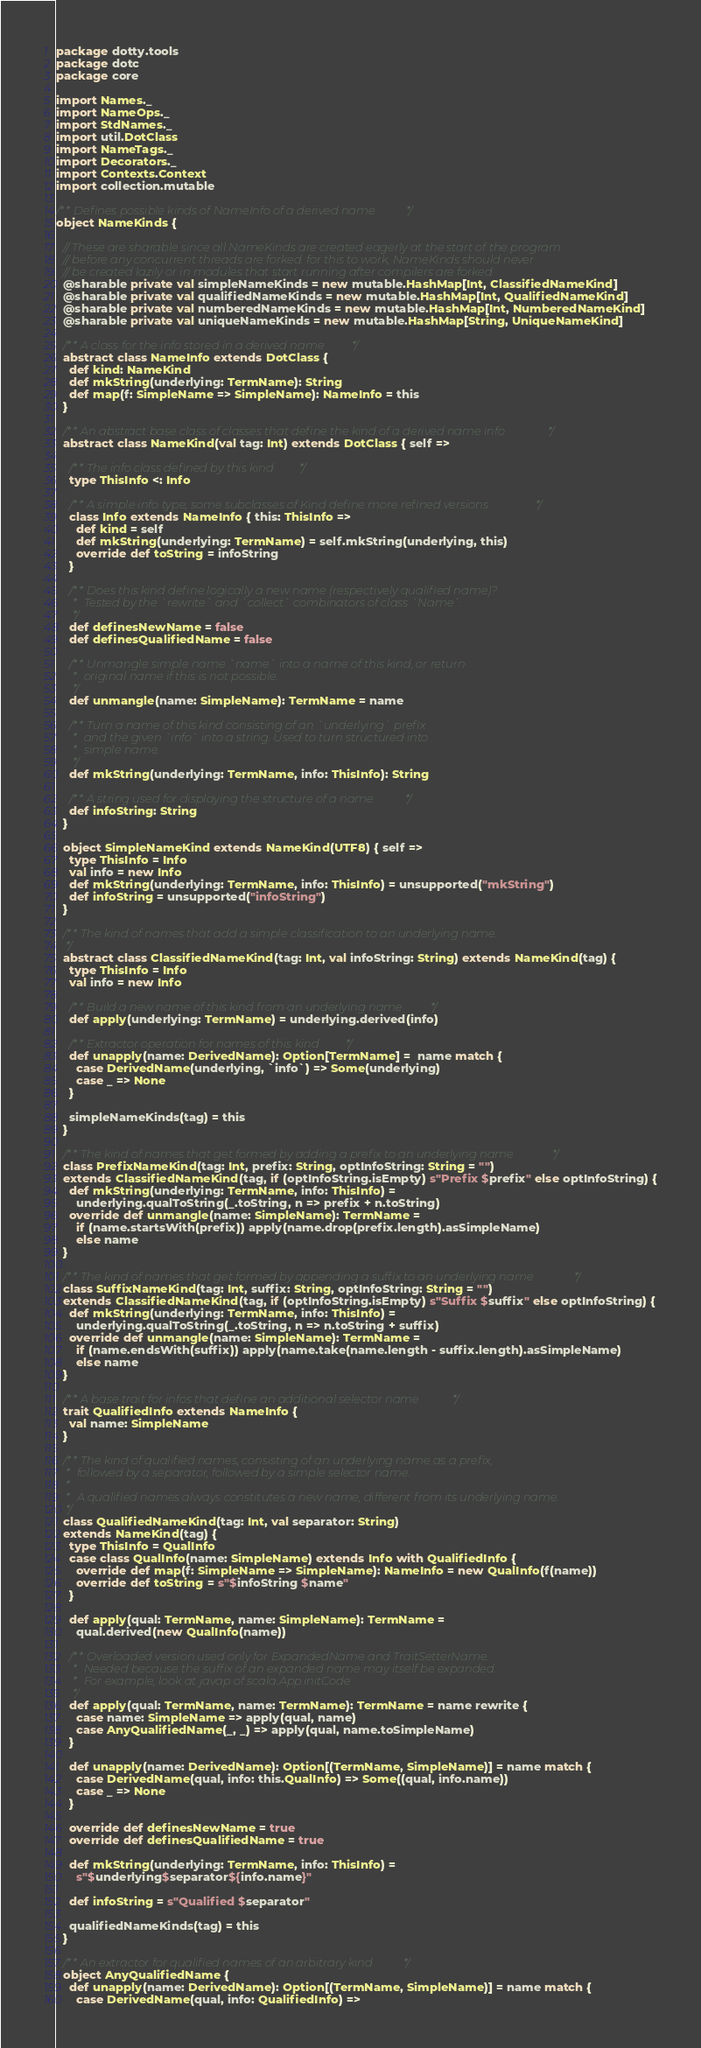Convert code to text. <code><loc_0><loc_0><loc_500><loc_500><_Scala_>package dotty.tools
package dotc
package core

import Names._
import NameOps._
import StdNames._
import util.DotClass
import NameTags._
import Decorators._
import Contexts.Context
import collection.mutable

/** Defines possible kinds of NameInfo of a derived name */
object NameKinds {

  // These are sharable since all NameKinds are created eagerly at the start of the program
  // before any concurrent threads are forked. for this to work, NameKinds should never
  // be created lazily or in modules that start running after compilers are forked.
  @sharable private val simpleNameKinds = new mutable.HashMap[Int, ClassifiedNameKind]
  @sharable private val qualifiedNameKinds = new mutable.HashMap[Int, QualifiedNameKind]
  @sharable private val numberedNameKinds = new mutable.HashMap[Int, NumberedNameKind]
  @sharable private val uniqueNameKinds = new mutable.HashMap[String, UniqueNameKind]

  /** A class for the info stored in a derived name */
  abstract class NameInfo extends DotClass {
    def kind: NameKind
    def mkString(underlying: TermName): String
    def map(f: SimpleName => SimpleName): NameInfo = this
  }

  /** An abstract base class of classes that define the kind of a derived name info */
  abstract class NameKind(val tag: Int) extends DotClass { self =>

    /** The info class defined by this kind */
    type ThisInfo <: Info

    /** A simple info type; some subclasses of Kind define more refined versions */
    class Info extends NameInfo { this: ThisInfo =>
      def kind = self
      def mkString(underlying: TermName) = self.mkString(underlying, this)
      override def toString = infoString
    }

    /** Does this kind define logically a new name (respectively qualified name)?
     *  Tested by the `rewrite` and `collect` combinators of class `Name`.
     */
    def definesNewName = false
    def definesQualifiedName = false

    /** Unmangle simple name `name` into a name of this kind, or return
     *  original name if this is not possible.
     */
    def unmangle(name: SimpleName): TermName = name

    /** Turn a name of this kind consisting of an `underlying` prefix
     *  and the given `info` into a string. Used to turn structured into
     *  simple name.
     */
    def mkString(underlying: TermName, info: ThisInfo): String

    /** A string used for displaying the structure of a name */
    def infoString: String
  }

  object SimpleNameKind extends NameKind(UTF8) { self =>
    type ThisInfo = Info
    val info = new Info
    def mkString(underlying: TermName, info: ThisInfo) = unsupported("mkString")
    def infoString = unsupported("infoString")
  }

  /** The kind of names that add a simple classification to an underlying name.
   */
  abstract class ClassifiedNameKind(tag: Int, val infoString: String) extends NameKind(tag) {
    type ThisInfo = Info
    val info = new Info

    /** Build a new name of this kind from an underlying name */
    def apply(underlying: TermName) = underlying.derived(info)

    /** Extractor operation for names of this kind */
    def unapply(name: DerivedName): Option[TermName] =  name match {
      case DerivedName(underlying, `info`) => Some(underlying)
      case _ => None
    }

    simpleNameKinds(tag) = this
  }

  /** The kind of names that get formed by adding a prefix to an underlying name */
  class PrefixNameKind(tag: Int, prefix: String, optInfoString: String = "")
  extends ClassifiedNameKind(tag, if (optInfoString.isEmpty) s"Prefix $prefix" else optInfoString) {
    def mkString(underlying: TermName, info: ThisInfo) =
      underlying.qualToString(_.toString, n => prefix + n.toString)
    override def unmangle(name: SimpleName): TermName =
      if (name.startsWith(prefix)) apply(name.drop(prefix.length).asSimpleName)
      else name
  }

  /** The kind of names that get formed by appending a suffix to an underlying name */
  class SuffixNameKind(tag: Int, suffix: String, optInfoString: String = "")
  extends ClassifiedNameKind(tag, if (optInfoString.isEmpty) s"Suffix $suffix" else optInfoString) {
    def mkString(underlying: TermName, info: ThisInfo) =
      underlying.qualToString(_.toString, n => n.toString + suffix)
    override def unmangle(name: SimpleName): TermName =
      if (name.endsWith(suffix)) apply(name.take(name.length - suffix.length).asSimpleName)
      else name
  }

  /** A base trait for infos that define an additional selector name */
  trait QualifiedInfo extends NameInfo {
    val name: SimpleName
  }

  /** The kind of qualified names, consisting of an underlying name as a prefix,
   *  followed by a separator, followed by a simple selector name.
   *
   *  A qualified names always constitutes a new name, different from its underlying name.
   */
  class QualifiedNameKind(tag: Int, val separator: String)
  extends NameKind(tag) {
    type ThisInfo = QualInfo
    case class QualInfo(name: SimpleName) extends Info with QualifiedInfo {
      override def map(f: SimpleName => SimpleName): NameInfo = new QualInfo(f(name))
      override def toString = s"$infoString $name"
    }

    def apply(qual: TermName, name: SimpleName): TermName =
      qual.derived(new QualInfo(name))

    /** Overloaded version used only for ExpandedName and TraitSetterName.
     *  Needed because the suffix of an expanded name may itself be expanded.
     *  For example, look at javap of scala.App.initCode
     */
    def apply(qual: TermName, name: TermName): TermName = name rewrite {
      case name: SimpleName => apply(qual, name)
      case AnyQualifiedName(_, _) => apply(qual, name.toSimpleName)
    }

    def unapply(name: DerivedName): Option[(TermName, SimpleName)] = name match {
      case DerivedName(qual, info: this.QualInfo) => Some((qual, info.name))
      case _ => None
    }

    override def definesNewName = true
    override def definesQualifiedName = true

    def mkString(underlying: TermName, info: ThisInfo) =
      s"$underlying$separator${info.name}"

    def infoString = s"Qualified $separator"

    qualifiedNameKinds(tag) = this
  }

  /** An extractor for qualified names of an arbitrary kind */
  object AnyQualifiedName {
    def unapply(name: DerivedName): Option[(TermName, SimpleName)] = name match {
      case DerivedName(qual, info: QualifiedInfo) =></code> 